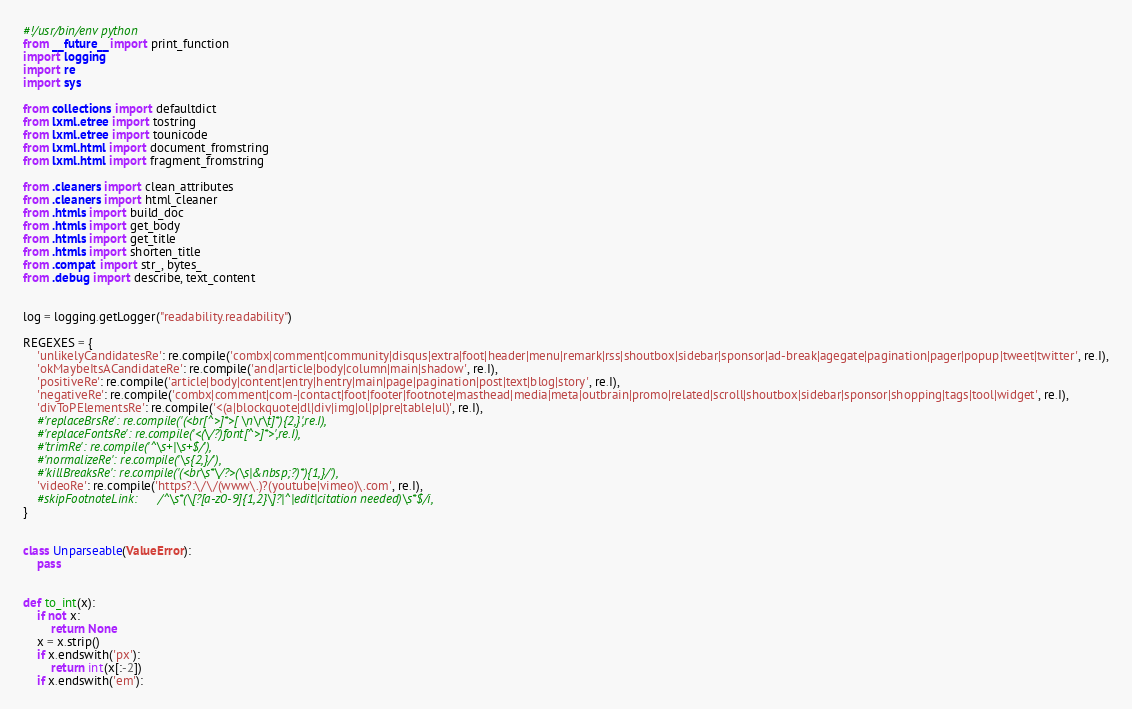<code> <loc_0><loc_0><loc_500><loc_500><_Python_>#!/usr/bin/env python
from __future__ import print_function
import logging
import re
import sys

from collections import defaultdict
from lxml.etree import tostring
from lxml.etree import tounicode
from lxml.html import document_fromstring
from lxml.html import fragment_fromstring

from .cleaners import clean_attributes
from .cleaners import html_cleaner
from .htmls import build_doc
from .htmls import get_body
from .htmls import get_title
from .htmls import shorten_title
from .compat import str_, bytes_
from .debug import describe, text_content


log = logging.getLogger("readability.readability")

REGEXES = {
    'unlikelyCandidatesRe': re.compile('combx|comment|community|disqus|extra|foot|header|menu|remark|rss|shoutbox|sidebar|sponsor|ad-break|agegate|pagination|pager|popup|tweet|twitter', re.I),
    'okMaybeItsACandidateRe': re.compile('and|article|body|column|main|shadow', re.I),
    'positiveRe': re.compile('article|body|content|entry|hentry|main|page|pagination|post|text|blog|story', re.I),
    'negativeRe': re.compile('combx|comment|com-|contact|foot|footer|footnote|masthead|media|meta|outbrain|promo|related|scroll|shoutbox|sidebar|sponsor|shopping|tags|tool|widget', re.I),
    'divToPElementsRe': re.compile('<(a|blockquote|dl|div|img|ol|p|pre|table|ul)', re.I),
    #'replaceBrsRe': re.compile('(<br[^>]*>[ \n\r\t]*){2,}',re.I),
    #'replaceFontsRe': re.compile('<(\/?)font[^>]*>',re.I),
    #'trimRe': re.compile('^\s+|\s+$/'),
    #'normalizeRe': re.compile('\s{2,}/'),
    #'killBreaksRe': re.compile('(<br\s*\/?>(\s|&nbsp;?)*){1,}/'),
    'videoRe': re.compile('https?:\/\/(www\.)?(youtube|vimeo)\.com', re.I),
    #skipFootnoteLink:      /^\s*(\[?[a-z0-9]{1,2}\]?|^|edit|citation needed)\s*$/i,
}


class Unparseable(ValueError):
    pass


def to_int(x):
    if not x:
        return None
    x = x.strip()
    if x.endswith('px'):
        return int(x[:-2])
    if x.endswith('em'):</code> 